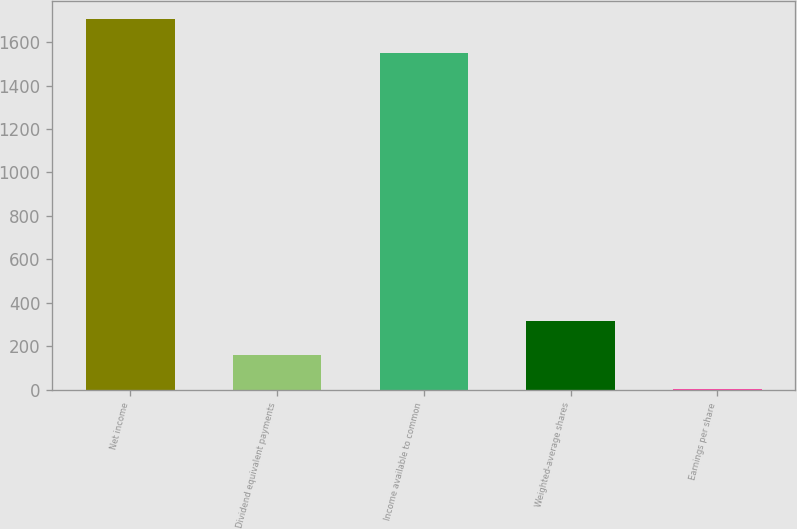Convert chart to OTSL. <chart><loc_0><loc_0><loc_500><loc_500><bar_chart><fcel>Net income<fcel>Dividend equivalent payments<fcel>Income available to common<fcel>Weighted-average shares<fcel>Earnings per share<nl><fcel>1705.09<fcel>160.22<fcel>1550<fcel>315.31<fcel>5.13<nl></chart> 